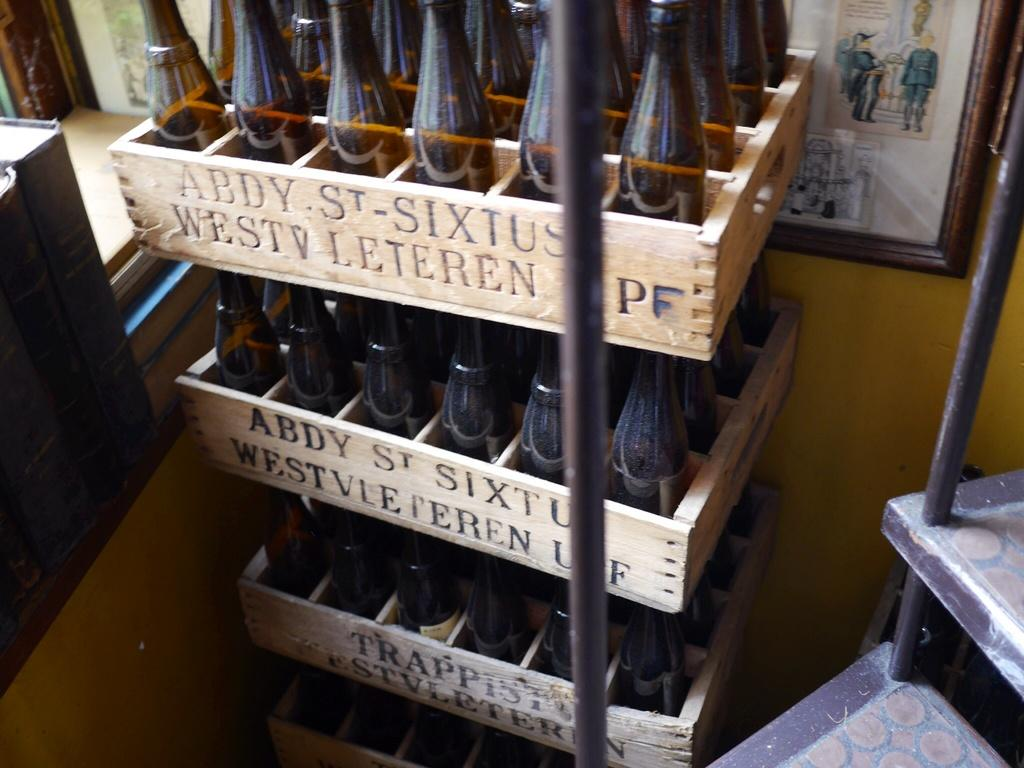Provide a one-sentence caption for the provided image. The wooden beverage crates say Abdy St. Sixtus. 